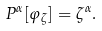Convert formula to latex. <formula><loc_0><loc_0><loc_500><loc_500>P ^ { \alpha } [ \varphi _ { \zeta } ] = \zeta ^ { \alpha } .</formula> 